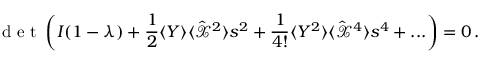Convert formula to latex. <formula><loc_0><loc_0><loc_500><loc_500>d e t \left ( I ( 1 - \lambda ) + \frac { 1 } { 2 } \langle Y \rangle \langle { \hat { \mathcal { X } } } ^ { 2 } \rangle s ^ { 2 } + \frac { 1 } { 4 ! } \langle Y ^ { 2 } \rangle \langle { \hat { \mathcal { X } } } ^ { 4 } \rangle s ^ { 4 } + \dots \right ) = 0 \, .</formula> 